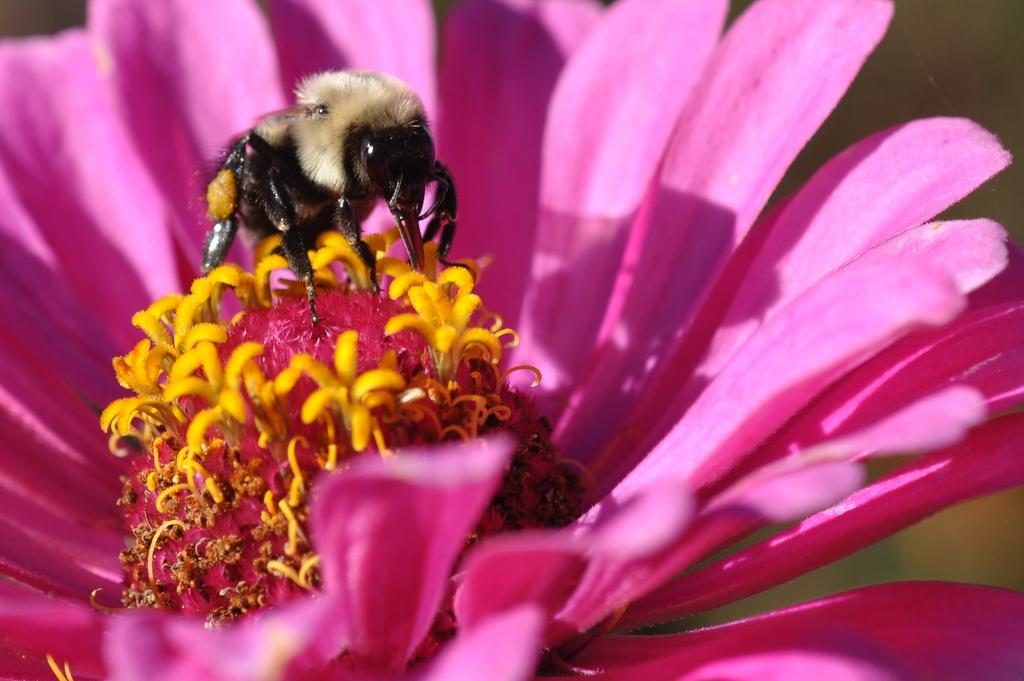What type of creature is in the image? There is an insect in the image. Can you describe the colors of the insect? The insect has cream, black, and orange colors. Where is the insect located in the image? The insect is on a flower. What colors can be seen on the flower? The flower has yellow and pink colors. How would you describe the background of the image? The background of the image is blurry. What type of bomb can be seen in the image? There is no bomb present in the image; it features an insect on a flower. Can you tell me how many springs are visible in the image? There is no reference to spring or any season in the image, so it cannot be determined from the picture. 